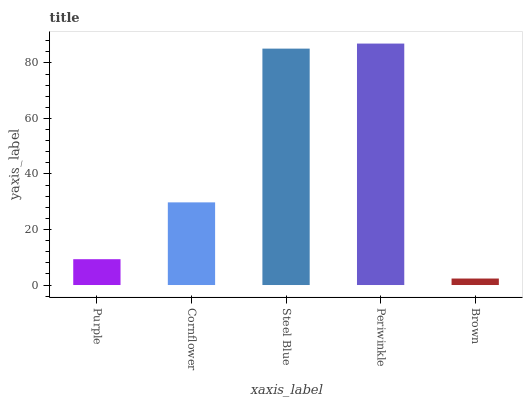Is Brown the minimum?
Answer yes or no. Yes. Is Periwinkle the maximum?
Answer yes or no. Yes. Is Cornflower the minimum?
Answer yes or no. No. Is Cornflower the maximum?
Answer yes or no. No. Is Cornflower greater than Purple?
Answer yes or no. Yes. Is Purple less than Cornflower?
Answer yes or no. Yes. Is Purple greater than Cornflower?
Answer yes or no. No. Is Cornflower less than Purple?
Answer yes or no. No. Is Cornflower the high median?
Answer yes or no. Yes. Is Cornflower the low median?
Answer yes or no. Yes. Is Steel Blue the high median?
Answer yes or no. No. Is Brown the low median?
Answer yes or no. No. 